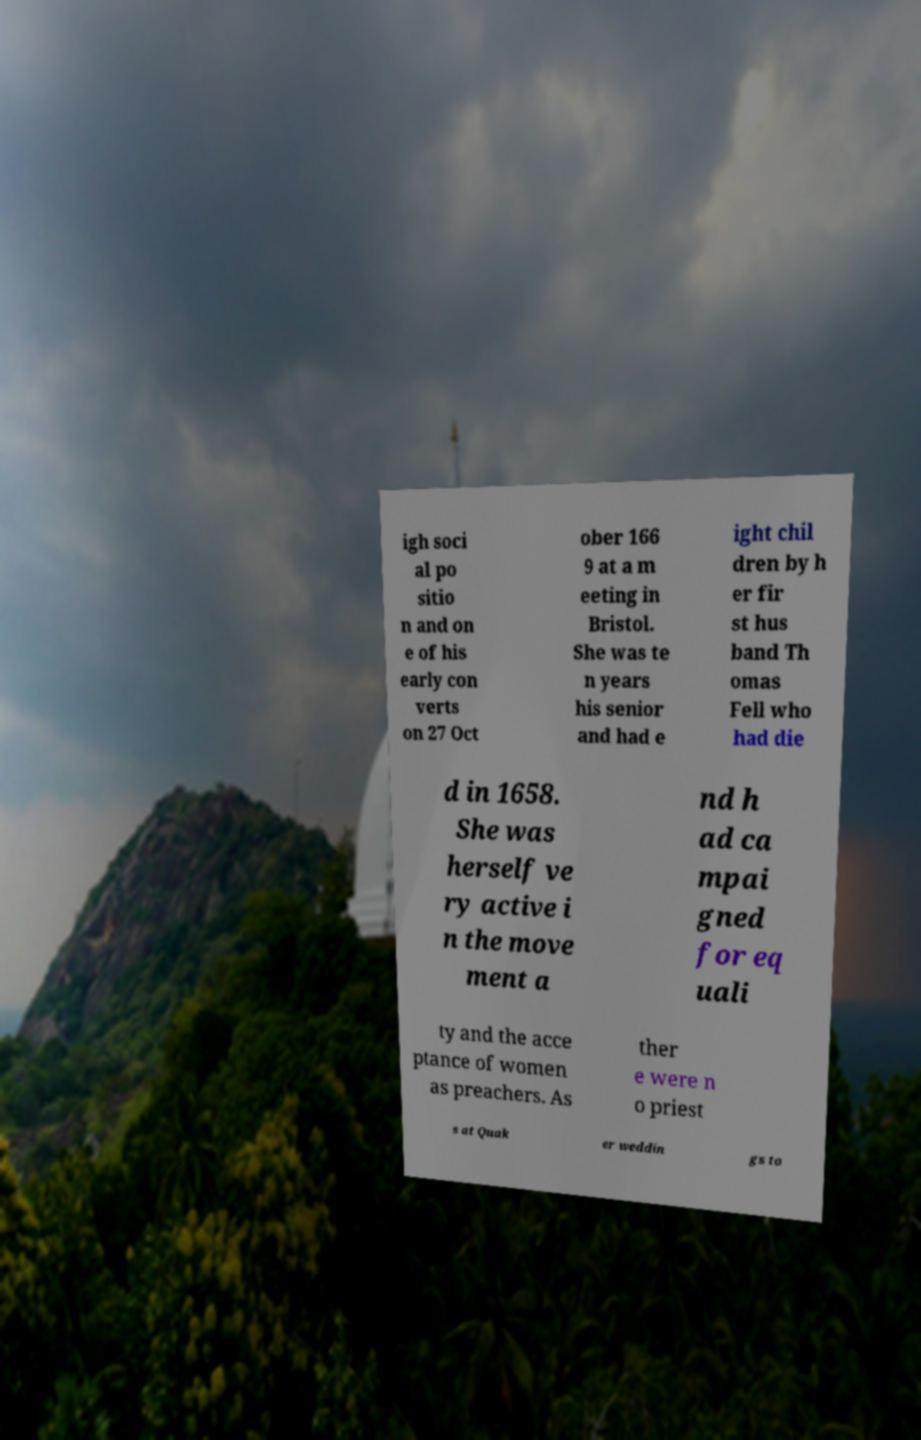Can you read and provide the text displayed in the image?This photo seems to have some interesting text. Can you extract and type it out for me? igh soci al po sitio n and on e of his early con verts on 27 Oct ober 166 9 at a m eeting in Bristol. She was te n years his senior and had e ight chil dren by h er fir st hus band Th omas Fell who had die d in 1658. She was herself ve ry active i n the move ment a nd h ad ca mpai gned for eq uali ty and the acce ptance of women as preachers. As ther e were n o priest s at Quak er weddin gs to 